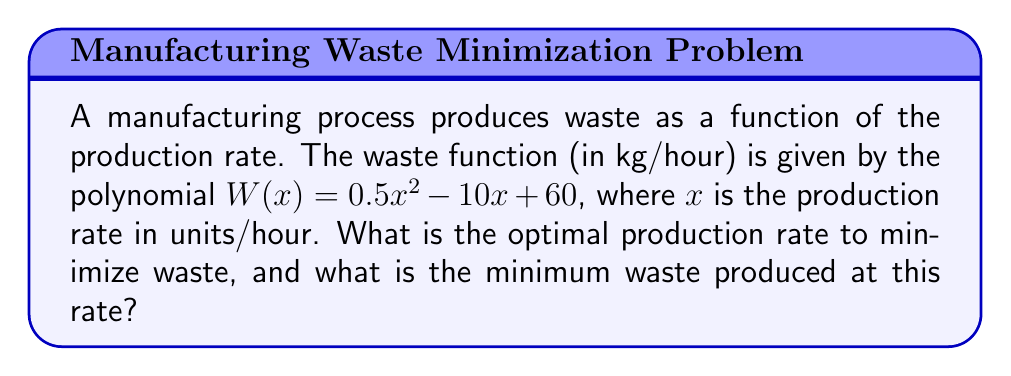Provide a solution to this math problem. To find the optimal production rate that minimizes waste, we need to follow these steps:

1. The waste function is a quadratic polynomial: $W(x) = 0.5x^2 - 10x + 60$

2. To find the minimum point, we need to calculate the vertex of the parabola. The x-coordinate of the vertex represents the optimal production rate.

3. For a quadratic function in the form $ax^2 + bx + c$, the x-coordinate of the vertex is given by $x = -\frac{b}{2a}$

4. In our case, $a = 0.5$, $b = -10$, and $c = 60$

5. Calculating the optimal production rate:
   $$x = -\frac{b}{2a} = -\frac{-10}{2(0.5)} = \frac{10}{1} = 10$$

6. The optimal production rate is 10 units/hour.

7. To find the minimum waste, we substitute $x = 10$ into the original waste function:
   $$W(10) = 0.5(10)^2 - 10(10) + 60$$
   $$W(10) = 0.5(100) - 100 + 60$$
   $$W(10) = 50 - 100 + 60 = 10$$

Therefore, the minimum waste produced is 10 kg/hour at the optimal production rate of 10 units/hour.
Answer: Optimal production rate: 10 units/hour; Minimum waste: 10 kg/hour 